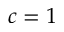<formula> <loc_0><loc_0><loc_500><loc_500>c = 1</formula> 